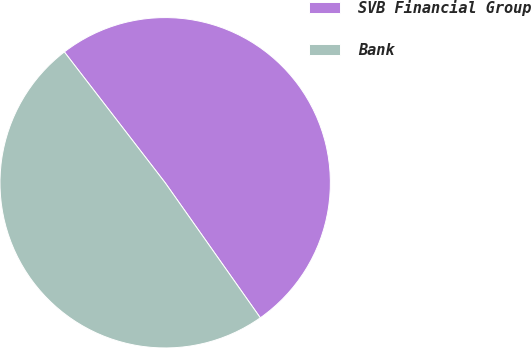Convert chart to OTSL. <chart><loc_0><loc_0><loc_500><loc_500><pie_chart><fcel>SVB Financial Group<fcel>Bank<nl><fcel>50.68%<fcel>49.32%<nl></chart> 